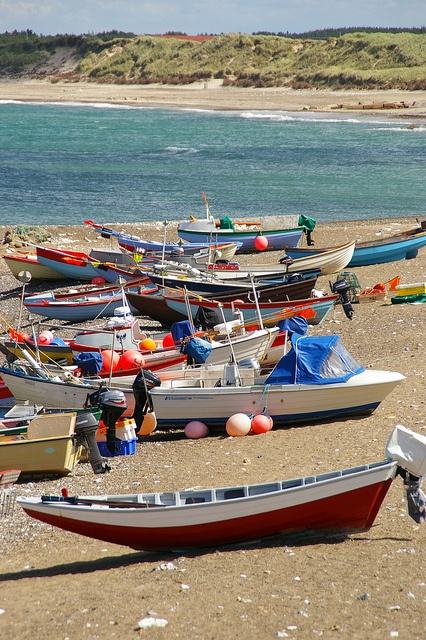Describe the objects in this image and their specific colors. I can see boat in darkgray, black, tan, and gray tones, boat in darkgray, maroon, black, and gray tones, boat in darkgray, gray, and black tones, boat in darkgray, ivory, gray, and black tones, and boat in darkgray, olive, tan, black, and khaki tones in this image. 